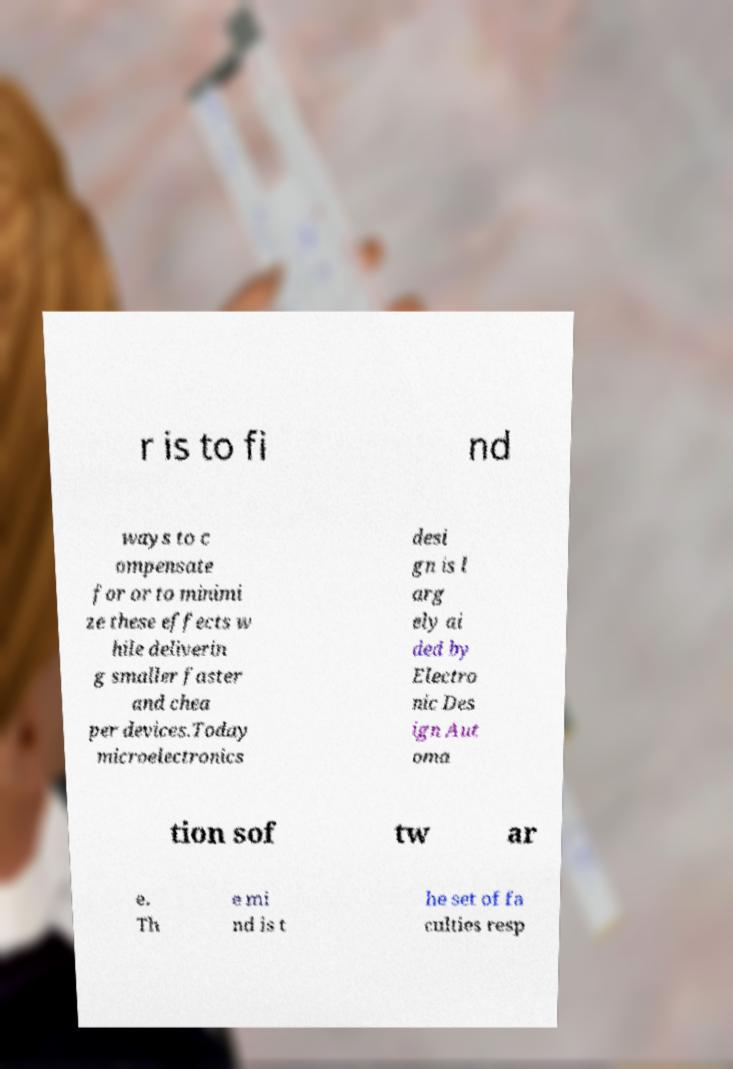What messages or text are displayed in this image? I need them in a readable, typed format. r is to fi nd ways to c ompensate for or to minimi ze these effects w hile deliverin g smaller faster and chea per devices.Today microelectronics desi gn is l arg ely ai ded by Electro nic Des ign Aut oma tion sof tw ar e. Th e mi nd is t he set of fa culties resp 